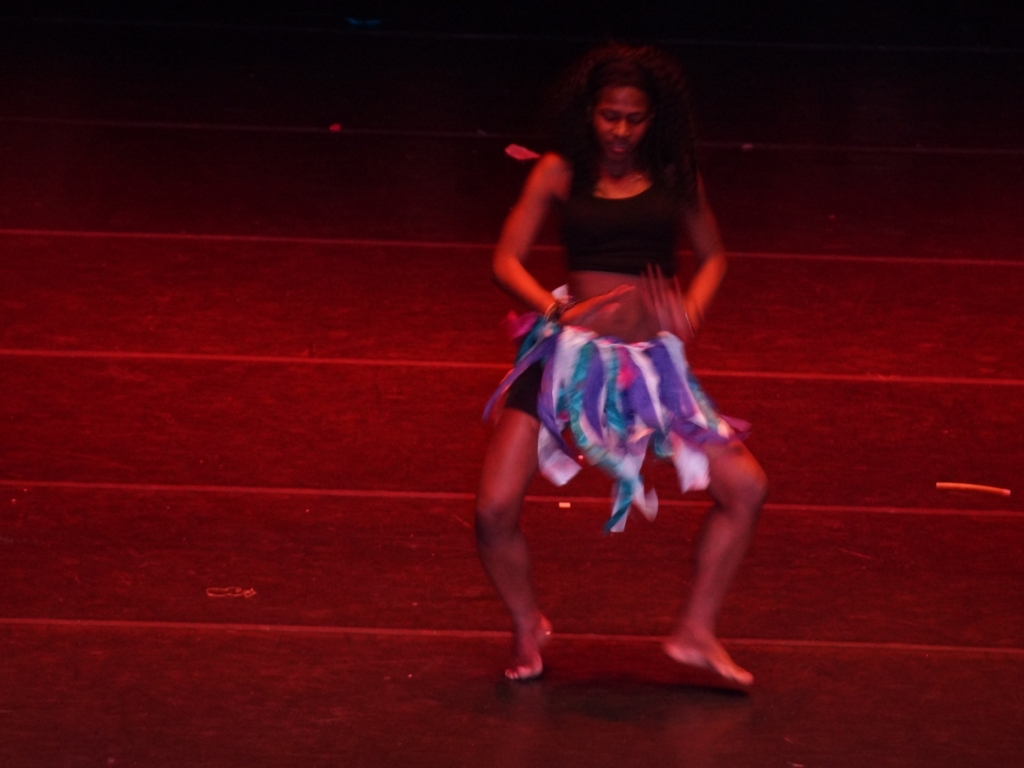How would you describe the composition of this image?
A. Well-balanced
B. Poor
C. Harmonious
Answer with the option's letter from the given choices directly. C. The composition appears to be Harmonious, capturing the dynamic movement of the dancer with a blurred effect that conveys motion. The image seems to focus on the dancer's expression and movement, which are central to the frame, creating an effect that suggests rhythm and artistic expression. 